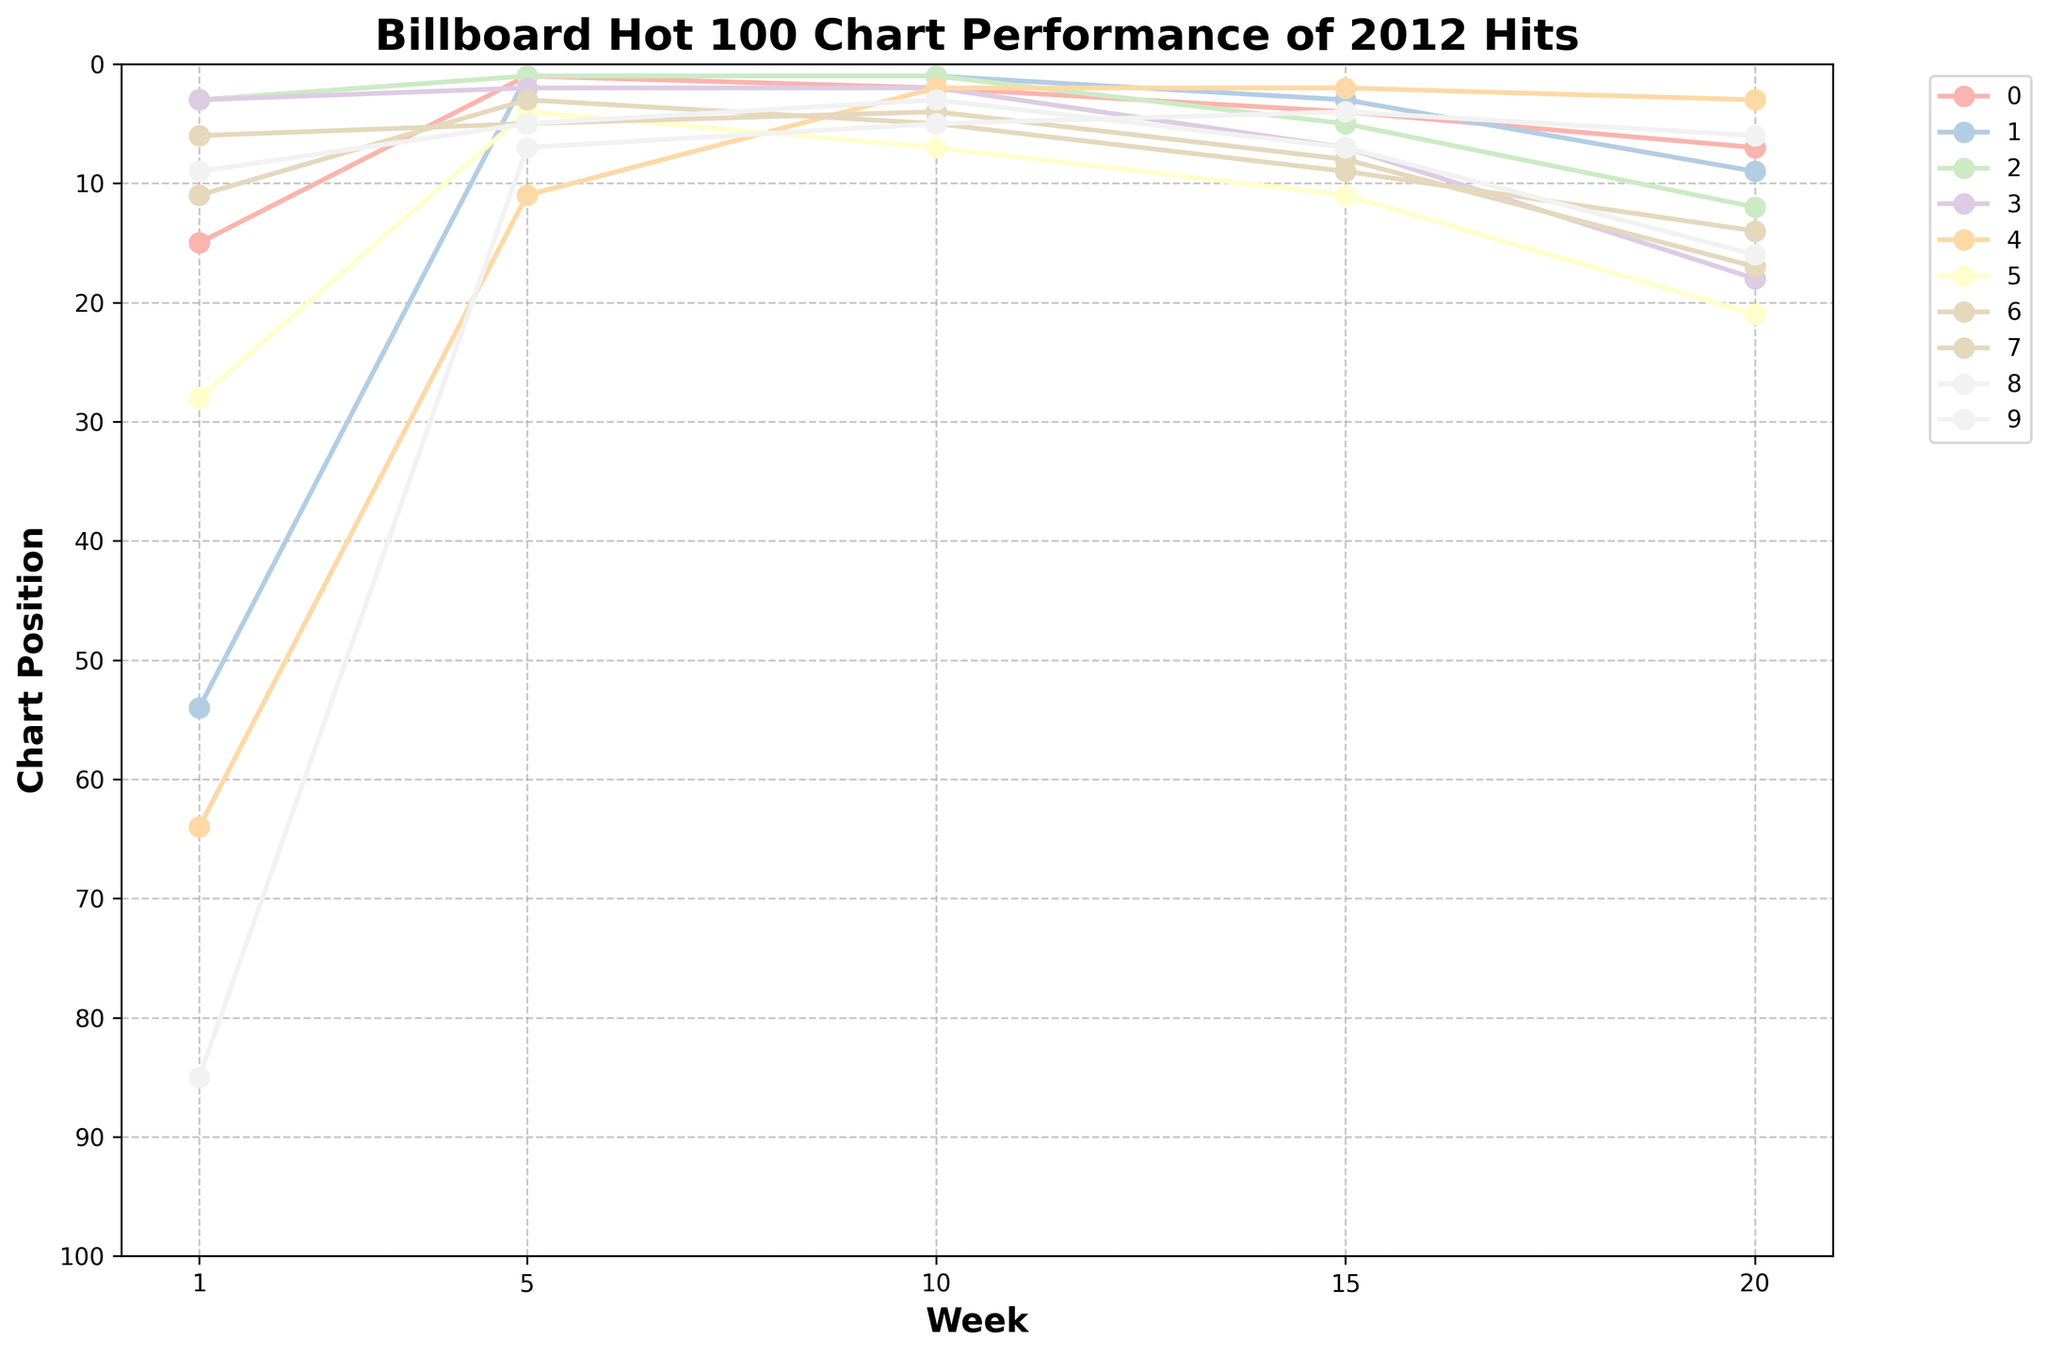What is the title of the plot? The title of the plot is displayed at the top of the chart. It provides an overview of the chart's content.
Answer: Billboard Hot 100 Chart Performance of 2012 Hits Which song had the highest peak position in the first week? To determine this, check the positions listed under "Week 1" and find the lowest value, as lower chart positions are better.
Answer: Call Me Maybe and We Are Young How many songs reached the number 1 position at any point within the 20 weeks? Count the number of lines that hit the number 1 position on the y-axis at any point along the x-axis (week).
Answer: 3 songs Which song performed best by the end of the 20 weeks? To determine the best performance at Week 20, find the song with the lowest chart position in Week 20.
Answer: Gangnam Style How did the chart position of "Lights" change from Week 1 to Week 20? Compare the position of "Lights" at Week 1 with its position at Week 20. Look at the intersection points on the y-axis for these weeks.
Answer: Improved from 85 to 6 What is the median chart position of "Some Nights" over the 5 weeks shown? List the chart positions for "Some Nights" over the 5 weeks and find the median value. Positions: 11, 3, 5, 9, 14
Answer: 9 Which song had the most significant improvement from its initial position by Week 20? Calculate the difference between Week 1 and Week 20 for each song and identify the song with the highest positive difference.
Answer: Lights Did "We Are Young" ever drop below position 10 during the first 20 weeks? Observe the line representing "We Are Young" and check if it ever reaches a value less than 10 on the y-axis.
Answer: No Which song spent the most weeks at the top position? Count the number of weeks each song spent at position 1 and identify the song with the highest count.
Answer: Somebody That I Used to Know How did "Gangnam Style" perform in comparison to "Call Me Maybe" during the first 15 weeks? Compare the chart lines of both songs from Week 1 to Week 15 to see which one had better (lower) positions over time.
Answer: Gangnam Style performed broadly better 